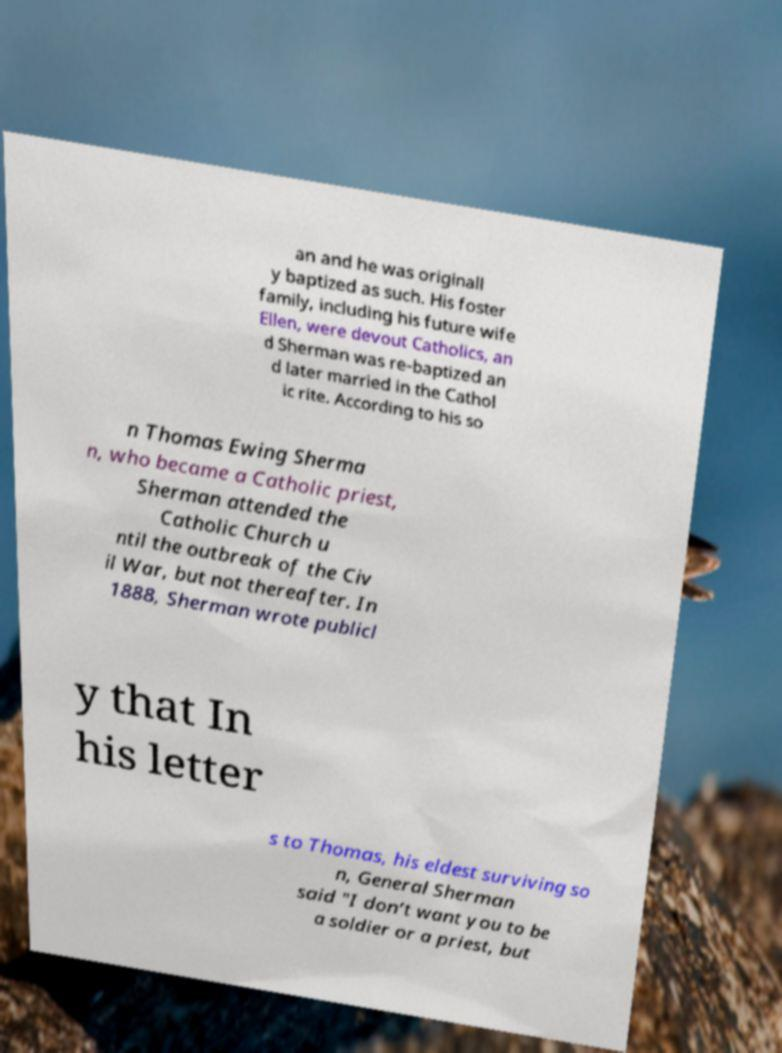Please identify and transcribe the text found in this image. an and he was originall y baptized as such. His foster family, including his future wife Ellen, were devout Catholics, an d Sherman was re-baptized an d later married in the Cathol ic rite. According to his so n Thomas Ewing Sherma n, who became a Catholic priest, Sherman attended the Catholic Church u ntil the outbreak of the Civ il War, but not thereafter. In 1888, Sherman wrote publicl y that In his letter s to Thomas, his eldest surviving so n, General Sherman said "I don’t want you to be a soldier or a priest, but 